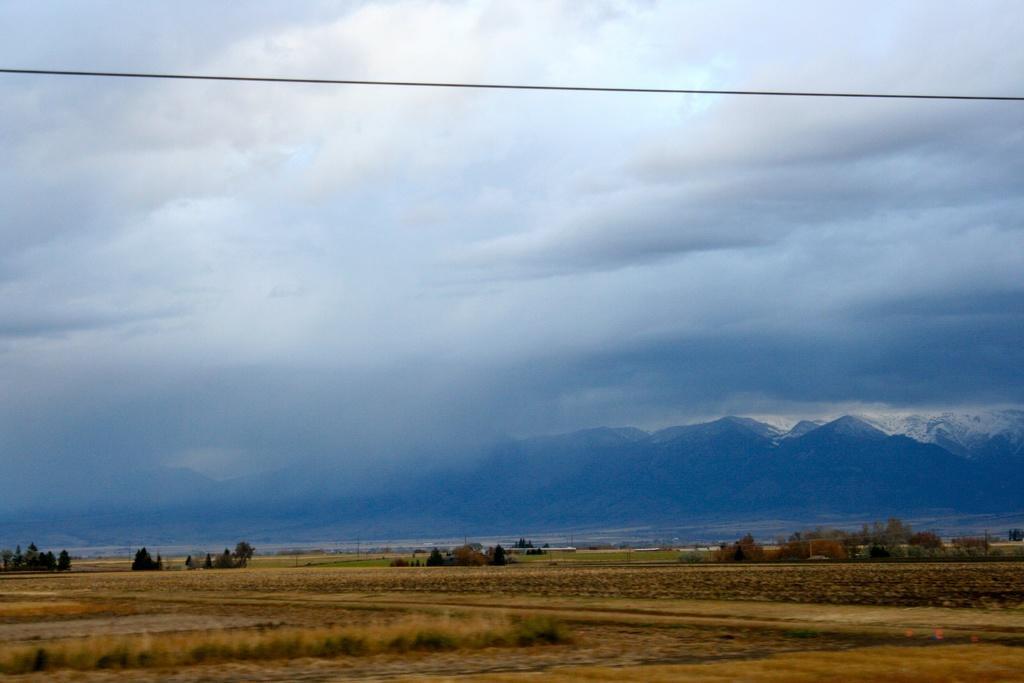How would you summarize this image in a sentence or two? In this image we can see sky with clouds, cable, mountains, ground, trees and lawn straw. 